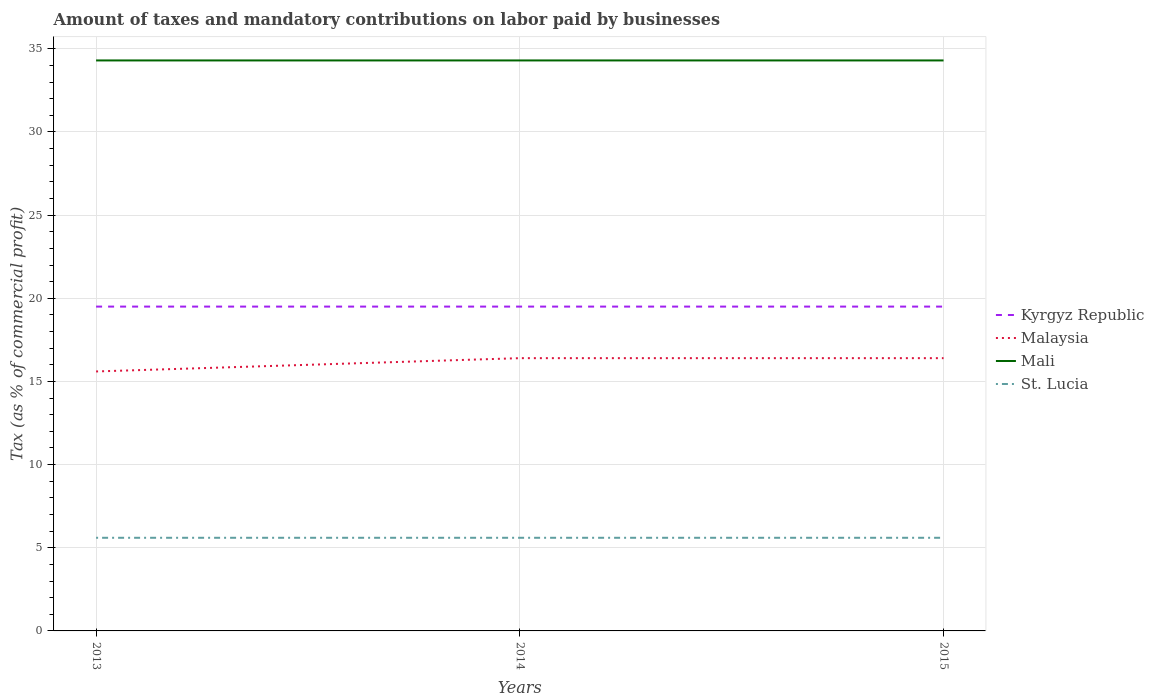How many different coloured lines are there?
Provide a short and direct response. 4. Does the line corresponding to Malaysia intersect with the line corresponding to Kyrgyz Republic?
Offer a very short reply. No. Is the number of lines equal to the number of legend labels?
Your answer should be very brief. Yes. What is the difference between the highest and the lowest percentage of taxes paid by businesses in St. Lucia?
Keep it short and to the point. 3. How many lines are there?
Your answer should be very brief. 4. What is the difference between two consecutive major ticks on the Y-axis?
Provide a short and direct response. 5. Are the values on the major ticks of Y-axis written in scientific E-notation?
Offer a very short reply. No. Does the graph contain any zero values?
Offer a very short reply. No. How many legend labels are there?
Offer a terse response. 4. What is the title of the graph?
Ensure brevity in your answer.  Amount of taxes and mandatory contributions on labor paid by businesses. Does "Pakistan" appear as one of the legend labels in the graph?
Provide a short and direct response. No. What is the label or title of the Y-axis?
Provide a short and direct response. Tax (as % of commercial profit). What is the Tax (as % of commercial profit) of Malaysia in 2013?
Provide a succinct answer. 15.6. What is the Tax (as % of commercial profit) in Mali in 2013?
Keep it short and to the point. 34.3. What is the Tax (as % of commercial profit) in St. Lucia in 2013?
Your answer should be very brief. 5.6. What is the Tax (as % of commercial profit) in Kyrgyz Republic in 2014?
Provide a short and direct response. 19.5. What is the Tax (as % of commercial profit) in Malaysia in 2014?
Make the answer very short. 16.4. What is the Tax (as % of commercial profit) in Mali in 2014?
Provide a succinct answer. 34.3. What is the Tax (as % of commercial profit) of St. Lucia in 2014?
Provide a short and direct response. 5.6. What is the Tax (as % of commercial profit) in Mali in 2015?
Keep it short and to the point. 34.3. Across all years, what is the maximum Tax (as % of commercial profit) in Mali?
Offer a terse response. 34.3. Across all years, what is the maximum Tax (as % of commercial profit) in St. Lucia?
Ensure brevity in your answer.  5.6. Across all years, what is the minimum Tax (as % of commercial profit) of Mali?
Offer a very short reply. 34.3. What is the total Tax (as % of commercial profit) of Kyrgyz Republic in the graph?
Make the answer very short. 58.5. What is the total Tax (as % of commercial profit) in Malaysia in the graph?
Give a very brief answer. 48.4. What is the total Tax (as % of commercial profit) of Mali in the graph?
Offer a very short reply. 102.9. What is the total Tax (as % of commercial profit) in St. Lucia in the graph?
Ensure brevity in your answer.  16.8. What is the difference between the Tax (as % of commercial profit) in Malaysia in 2013 and that in 2014?
Your answer should be very brief. -0.8. What is the difference between the Tax (as % of commercial profit) in St. Lucia in 2013 and that in 2014?
Keep it short and to the point. 0. What is the difference between the Tax (as % of commercial profit) of Kyrgyz Republic in 2013 and that in 2015?
Make the answer very short. 0. What is the difference between the Tax (as % of commercial profit) of Kyrgyz Republic in 2014 and that in 2015?
Keep it short and to the point. 0. What is the difference between the Tax (as % of commercial profit) of Malaysia in 2014 and that in 2015?
Keep it short and to the point. 0. What is the difference between the Tax (as % of commercial profit) of Mali in 2014 and that in 2015?
Make the answer very short. 0. What is the difference between the Tax (as % of commercial profit) of St. Lucia in 2014 and that in 2015?
Provide a short and direct response. 0. What is the difference between the Tax (as % of commercial profit) of Kyrgyz Republic in 2013 and the Tax (as % of commercial profit) of Mali in 2014?
Offer a very short reply. -14.8. What is the difference between the Tax (as % of commercial profit) of Malaysia in 2013 and the Tax (as % of commercial profit) of Mali in 2014?
Give a very brief answer. -18.7. What is the difference between the Tax (as % of commercial profit) in Mali in 2013 and the Tax (as % of commercial profit) in St. Lucia in 2014?
Your answer should be very brief. 28.7. What is the difference between the Tax (as % of commercial profit) in Kyrgyz Republic in 2013 and the Tax (as % of commercial profit) in Malaysia in 2015?
Keep it short and to the point. 3.1. What is the difference between the Tax (as % of commercial profit) in Kyrgyz Republic in 2013 and the Tax (as % of commercial profit) in Mali in 2015?
Keep it short and to the point. -14.8. What is the difference between the Tax (as % of commercial profit) in Kyrgyz Republic in 2013 and the Tax (as % of commercial profit) in St. Lucia in 2015?
Ensure brevity in your answer.  13.9. What is the difference between the Tax (as % of commercial profit) of Malaysia in 2013 and the Tax (as % of commercial profit) of Mali in 2015?
Offer a terse response. -18.7. What is the difference between the Tax (as % of commercial profit) in Malaysia in 2013 and the Tax (as % of commercial profit) in St. Lucia in 2015?
Make the answer very short. 10. What is the difference between the Tax (as % of commercial profit) in Mali in 2013 and the Tax (as % of commercial profit) in St. Lucia in 2015?
Your answer should be compact. 28.7. What is the difference between the Tax (as % of commercial profit) of Kyrgyz Republic in 2014 and the Tax (as % of commercial profit) of Mali in 2015?
Your response must be concise. -14.8. What is the difference between the Tax (as % of commercial profit) in Malaysia in 2014 and the Tax (as % of commercial profit) in Mali in 2015?
Provide a short and direct response. -17.9. What is the difference between the Tax (as % of commercial profit) of Malaysia in 2014 and the Tax (as % of commercial profit) of St. Lucia in 2015?
Offer a terse response. 10.8. What is the difference between the Tax (as % of commercial profit) of Mali in 2014 and the Tax (as % of commercial profit) of St. Lucia in 2015?
Your answer should be compact. 28.7. What is the average Tax (as % of commercial profit) in Kyrgyz Republic per year?
Keep it short and to the point. 19.5. What is the average Tax (as % of commercial profit) of Malaysia per year?
Provide a short and direct response. 16.13. What is the average Tax (as % of commercial profit) of Mali per year?
Offer a very short reply. 34.3. What is the average Tax (as % of commercial profit) in St. Lucia per year?
Provide a succinct answer. 5.6. In the year 2013, what is the difference between the Tax (as % of commercial profit) in Kyrgyz Republic and Tax (as % of commercial profit) in Malaysia?
Keep it short and to the point. 3.9. In the year 2013, what is the difference between the Tax (as % of commercial profit) of Kyrgyz Republic and Tax (as % of commercial profit) of Mali?
Give a very brief answer. -14.8. In the year 2013, what is the difference between the Tax (as % of commercial profit) of Kyrgyz Republic and Tax (as % of commercial profit) of St. Lucia?
Make the answer very short. 13.9. In the year 2013, what is the difference between the Tax (as % of commercial profit) of Malaysia and Tax (as % of commercial profit) of Mali?
Offer a very short reply. -18.7. In the year 2013, what is the difference between the Tax (as % of commercial profit) of Malaysia and Tax (as % of commercial profit) of St. Lucia?
Offer a terse response. 10. In the year 2013, what is the difference between the Tax (as % of commercial profit) in Mali and Tax (as % of commercial profit) in St. Lucia?
Ensure brevity in your answer.  28.7. In the year 2014, what is the difference between the Tax (as % of commercial profit) in Kyrgyz Republic and Tax (as % of commercial profit) in Malaysia?
Give a very brief answer. 3.1. In the year 2014, what is the difference between the Tax (as % of commercial profit) in Kyrgyz Republic and Tax (as % of commercial profit) in Mali?
Give a very brief answer. -14.8. In the year 2014, what is the difference between the Tax (as % of commercial profit) of Malaysia and Tax (as % of commercial profit) of Mali?
Make the answer very short. -17.9. In the year 2014, what is the difference between the Tax (as % of commercial profit) in Malaysia and Tax (as % of commercial profit) in St. Lucia?
Give a very brief answer. 10.8. In the year 2014, what is the difference between the Tax (as % of commercial profit) in Mali and Tax (as % of commercial profit) in St. Lucia?
Your answer should be very brief. 28.7. In the year 2015, what is the difference between the Tax (as % of commercial profit) of Kyrgyz Republic and Tax (as % of commercial profit) of Mali?
Provide a succinct answer. -14.8. In the year 2015, what is the difference between the Tax (as % of commercial profit) in Kyrgyz Republic and Tax (as % of commercial profit) in St. Lucia?
Give a very brief answer. 13.9. In the year 2015, what is the difference between the Tax (as % of commercial profit) of Malaysia and Tax (as % of commercial profit) of Mali?
Make the answer very short. -17.9. In the year 2015, what is the difference between the Tax (as % of commercial profit) of Mali and Tax (as % of commercial profit) of St. Lucia?
Offer a terse response. 28.7. What is the ratio of the Tax (as % of commercial profit) in Kyrgyz Republic in 2013 to that in 2014?
Your answer should be very brief. 1. What is the ratio of the Tax (as % of commercial profit) in Malaysia in 2013 to that in 2014?
Offer a very short reply. 0.95. What is the ratio of the Tax (as % of commercial profit) of Mali in 2013 to that in 2014?
Your answer should be compact. 1. What is the ratio of the Tax (as % of commercial profit) of St. Lucia in 2013 to that in 2014?
Make the answer very short. 1. What is the ratio of the Tax (as % of commercial profit) in Kyrgyz Republic in 2013 to that in 2015?
Ensure brevity in your answer.  1. What is the ratio of the Tax (as % of commercial profit) in Malaysia in 2013 to that in 2015?
Give a very brief answer. 0.95. What is the ratio of the Tax (as % of commercial profit) in St. Lucia in 2013 to that in 2015?
Your response must be concise. 1. What is the ratio of the Tax (as % of commercial profit) in Kyrgyz Republic in 2014 to that in 2015?
Keep it short and to the point. 1. What is the ratio of the Tax (as % of commercial profit) in St. Lucia in 2014 to that in 2015?
Keep it short and to the point. 1. What is the difference between the highest and the second highest Tax (as % of commercial profit) in Malaysia?
Give a very brief answer. 0. What is the difference between the highest and the second highest Tax (as % of commercial profit) in Mali?
Provide a succinct answer. 0. What is the difference between the highest and the lowest Tax (as % of commercial profit) of Malaysia?
Keep it short and to the point. 0.8. What is the difference between the highest and the lowest Tax (as % of commercial profit) in Mali?
Give a very brief answer. 0. 